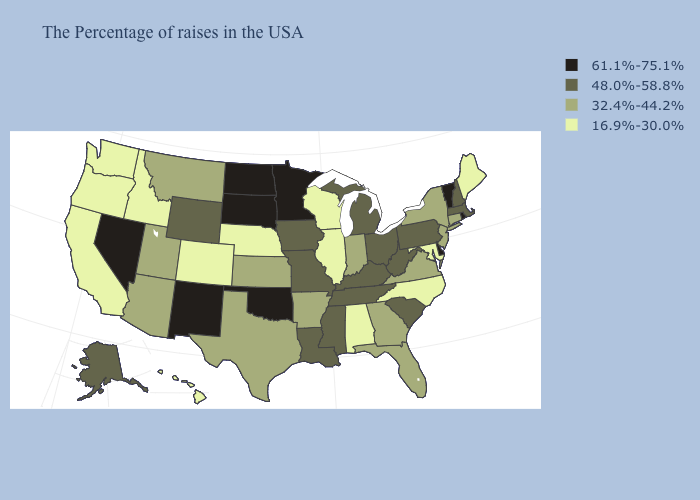What is the lowest value in states that border Nevada?
Give a very brief answer. 16.9%-30.0%. Which states have the lowest value in the Northeast?
Quick response, please. Maine. Name the states that have a value in the range 61.1%-75.1%?
Answer briefly. Rhode Island, Vermont, Delaware, Minnesota, Oklahoma, South Dakota, North Dakota, New Mexico, Nevada. Among the states that border Montana , which have the lowest value?
Give a very brief answer. Idaho. What is the highest value in the USA?
Be succinct. 61.1%-75.1%. Name the states that have a value in the range 16.9%-30.0%?
Keep it brief. Maine, Maryland, North Carolina, Alabama, Wisconsin, Illinois, Nebraska, Colorado, Idaho, California, Washington, Oregon, Hawaii. Does the map have missing data?
Quick response, please. No. Among the states that border New Hampshire , which have the highest value?
Answer briefly. Vermont. Name the states that have a value in the range 61.1%-75.1%?
Write a very short answer. Rhode Island, Vermont, Delaware, Minnesota, Oklahoma, South Dakota, North Dakota, New Mexico, Nevada. What is the value of West Virginia?
Keep it brief. 48.0%-58.8%. Name the states that have a value in the range 16.9%-30.0%?
Give a very brief answer. Maine, Maryland, North Carolina, Alabama, Wisconsin, Illinois, Nebraska, Colorado, Idaho, California, Washington, Oregon, Hawaii. Which states have the lowest value in the USA?
Short answer required. Maine, Maryland, North Carolina, Alabama, Wisconsin, Illinois, Nebraska, Colorado, Idaho, California, Washington, Oregon, Hawaii. What is the value of Oklahoma?
Short answer required. 61.1%-75.1%. How many symbols are there in the legend?
Short answer required. 4. Name the states that have a value in the range 32.4%-44.2%?
Be succinct. Connecticut, New York, New Jersey, Virginia, Florida, Georgia, Indiana, Arkansas, Kansas, Texas, Utah, Montana, Arizona. 